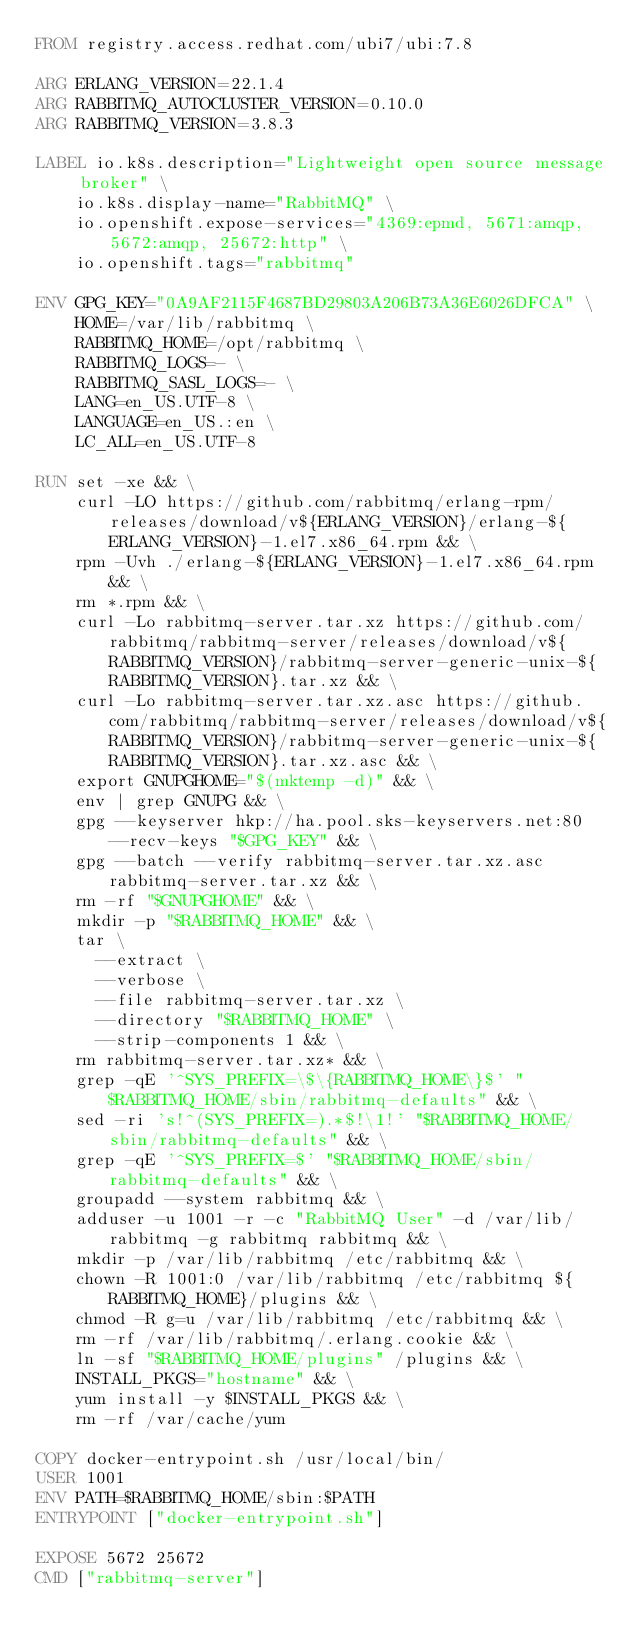Convert code to text. <code><loc_0><loc_0><loc_500><loc_500><_Dockerfile_>FROM registry.access.redhat.com/ubi7/ubi:7.8

ARG ERLANG_VERSION=22.1.4
ARG RABBITMQ_AUTOCLUSTER_VERSION=0.10.0
ARG RABBITMQ_VERSION=3.8.3

LABEL io.k8s.description="Lightweight open source message broker" \
    io.k8s.display-name="RabbitMQ" \
    io.openshift.expose-services="4369:epmd, 5671:amqp, 5672:amqp, 25672:http" \
    io.openshift.tags="rabbitmq"

ENV GPG_KEY="0A9AF2115F4687BD29803A206B73A36E6026DFCA" \
    HOME=/var/lib/rabbitmq \
    RABBITMQ_HOME=/opt/rabbitmq \
    RABBITMQ_LOGS=- \
    RABBITMQ_SASL_LOGS=- \
    LANG=en_US.UTF-8 \
    LANGUAGE=en_US.:en \
    LC_ALL=en_US.UTF-8

RUN set -xe && \
    curl -LO https://github.com/rabbitmq/erlang-rpm/releases/download/v${ERLANG_VERSION}/erlang-${ERLANG_VERSION}-1.el7.x86_64.rpm && \
    rpm -Uvh ./erlang-${ERLANG_VERSION}-1.el7.x86_64.rpm && \
    rm *.rpm && \
    curl -Lo rabbitmq-server.tar.xz https://github.com/rabbitmq/rabbitmq-server/releases/download/v${RABBITMQ_VERSION}/rabbitmq-server-generic-unix-${RABBITMQ_VERSION}.tar.xz && \
    curl -Lo rabbitmq-server.tar.xz.asc https://github.com/rabbitmq/rabbitmq-server/releases/download/v${RABBITMQ_VERSION}/rabbitmq-server-generic-unix-${RABBITMQ_VERSION}.tar.xz.asc && \
    export GNUPGHOME="$(mktemp -d)" && \
    env | grep GNUPG && \
    gpg --keyserver hkp://ha.pool.sks-keyservers.net:80 --recv-keys "$GPG_KEY" && \
    gpg --batch --verify rabbitmq-server.tar.xz.asc rabbitmq-server.tar.xz && \
    rm -rf "$GNUPGHOME" && \
    mkdir -p "$RABBITMQ_HOME" && \
    tar \
      --extract \
      --verbose \
      --file rabbitmq-server.tar.xz \
      --directory "$RABBITMQ_HOME" \
      --strip-components 1 && \
    rm rabbitmq-server.tar.xz* && \
    grep -qE '^SYS_PREFIX=\$\{RABBITMQ_HOME\}$' "$RABBITMQ_HOME/sbin/rabbitmq-defaults" && \
    sed -ri 's!^(SYS_PREFIX=).*$!\1!' "$RABBITMQ_HOME/sbin/rabbitmq-defaults" && \
    grep -qE '^SYS_PREFIX=$' "$RABBITMQ_HOME/sbin/rabbitmq-defaults" && \
    groupadd --system rabbitmq && \
    adduser -u 1001 -r -c "RabbitMQ User" -d /var/lib/rabbitmq -g rabbitmq rabbitmq && \
    mkdir -p /var/lib/rabbitmq /etc/rabbitmq && \
    chown -R 1001:0 /var/lib/rabbitmq /etc/rabbitmq ${RABBITMQ_HOME}/plugins && \
    chmod -R g=u /var/lib/rabbitmq /etc/rabbitmq && \
    rm -rf /var/lib/rabbitmq/.erlang.cookie && \
    ln -sf "$RABBITMQ_HOME/plugins" /plugins && \
    INSTALL_PKGS="hostname" && \
    yum install -y $INSTALL_PKGS && \
    rm -rf /var/cache/yum

COPY docker-entrypoint.sh /usr/local/bin/
USER 1001
ENV PATH=$RABBITMQ_HOME/sbin:$PATH
ENTRYPOINT ["docker-entrypoint.sh"]

EXPOSE 5672 25672
CMD ["rabbitmq-server"]
</code> 